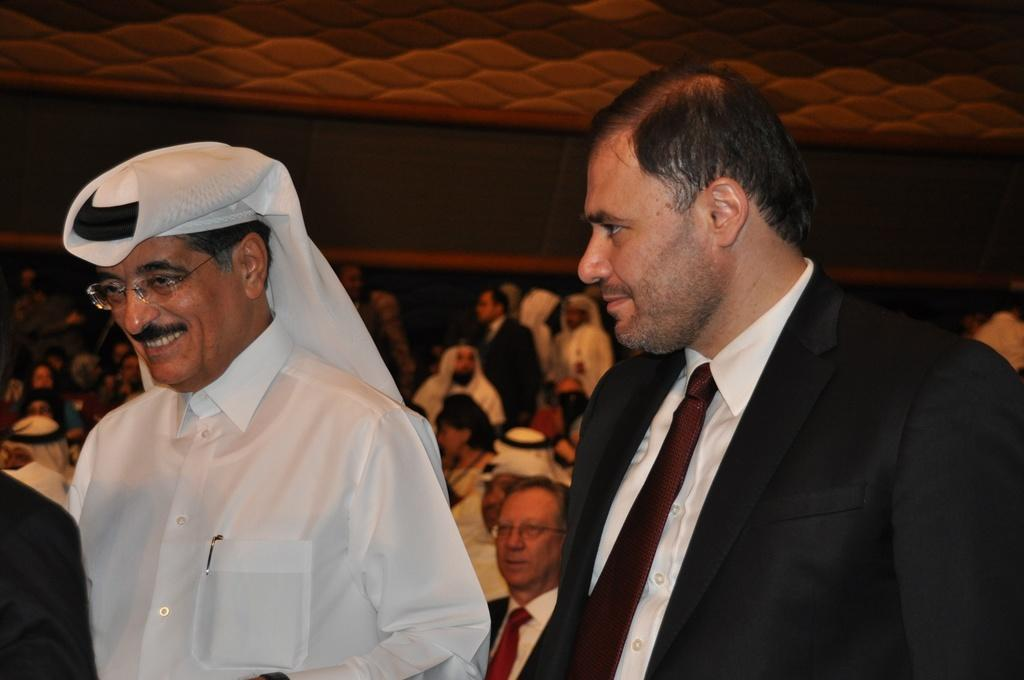How many men are in the foreground of the image? There are two men in the foreground of the image. What can be seen in the background of the image? There are many other people in the background of the image. What might be happening in the image based on the presence of multiple people? It appears that an event is being conducted in the image. What type of ground can be seen in the image? There is no specific ground mentioned or visible in the image. Is this a market or school event in the image? The image does not provide enough information to determine if it is a market or school event. 